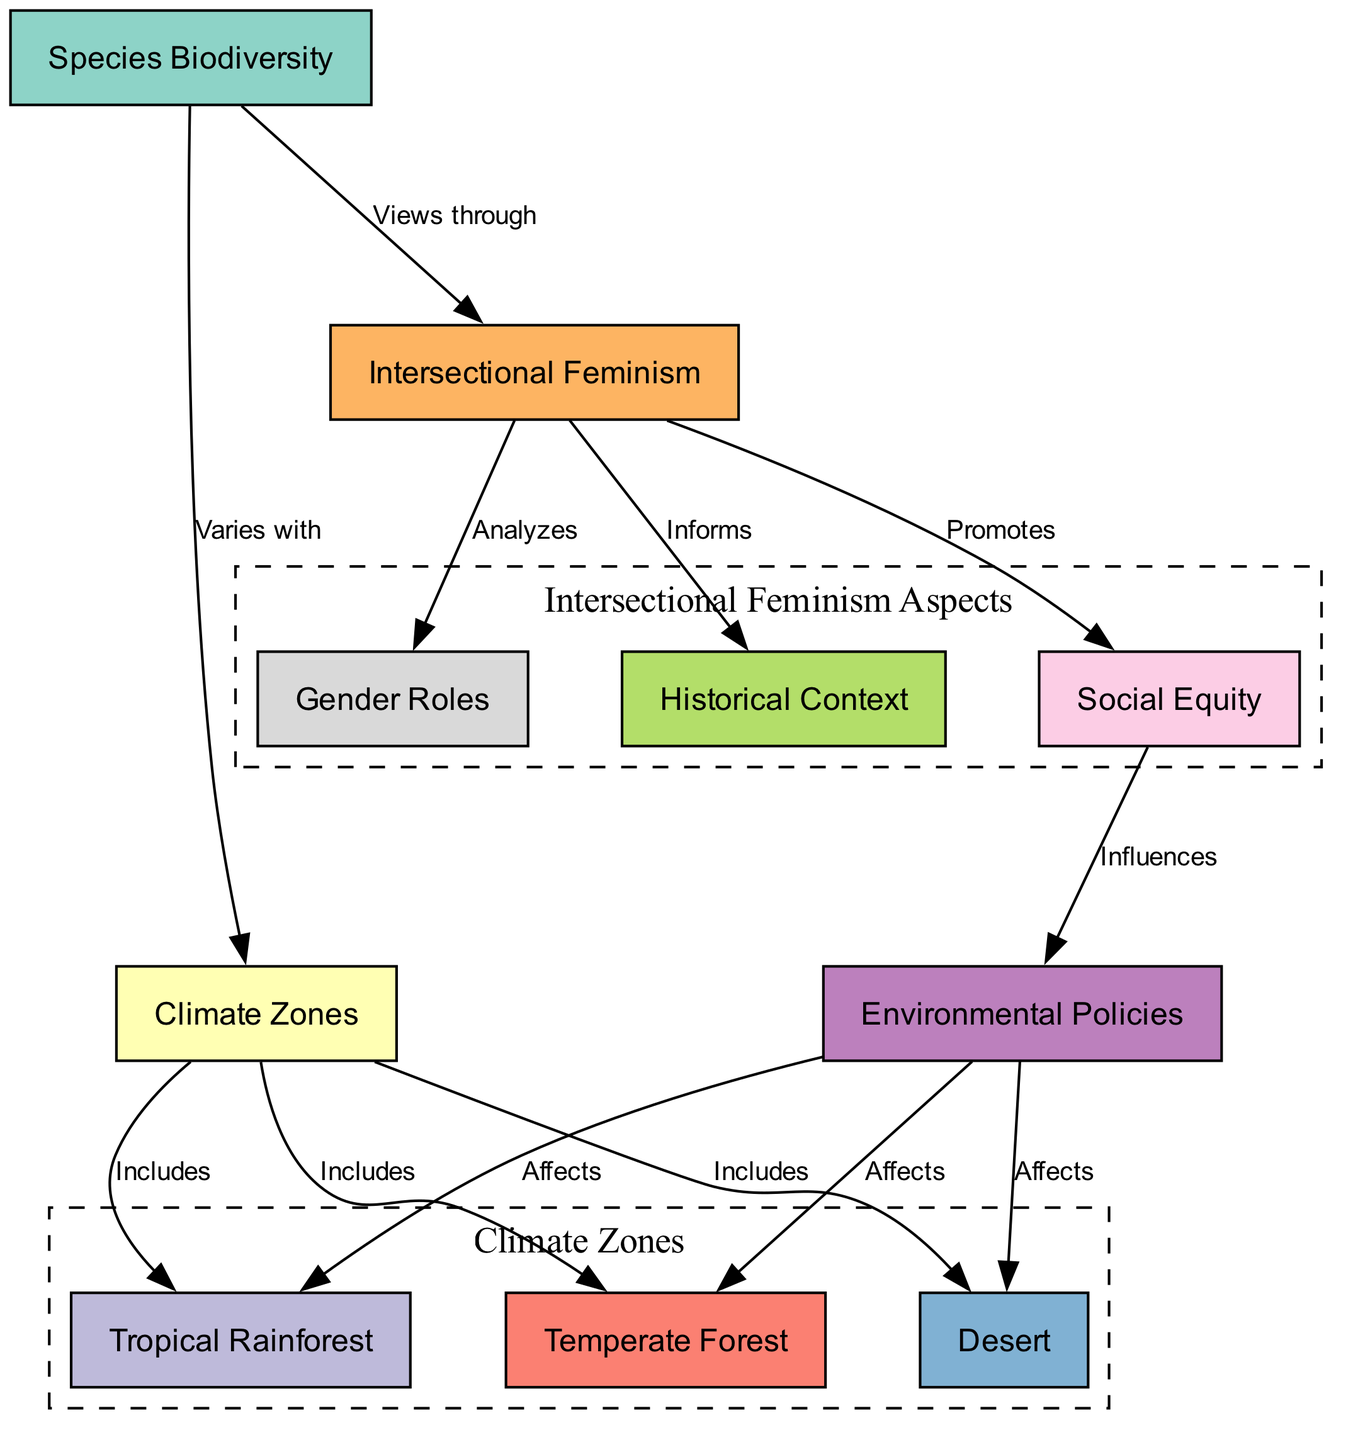What are the three climate zones included in the diagram? The diagram lists three specific climate zones that fall under the "Includes" relationship from the "Climate Zones" node: Tropical Rainforest, Temperate Forest, and Desert.
Answer: Tropical Rainforest, Temperate Forest, Desert How many nodes are present in the diagram? By counting all the distinct nodes listed in the diagram, including Species Biodiversity, Climate Zones, the three specific climate zones, Intersectional Feminism, and its related aspects, we find a total of ten nodes.
Answer: Ten What does intersectional feminism analyze according to the diagram? The diagram indicates that Intersectional Feminism analyzes gender roles. This is shown by the directed edge from the Intersectional Feminism node to the Gender Roles node, labeled "Analyzes."
Answer: Gender Roles Which node is influenced by social equity according to the diagram? The diagram shows that social equity influences environmental policies. There is a direct edge from the Social Equity node to the Environmental Policies node labeled "Influences."
Answer: Environmental Policies How many edges are connected to the climate zones node? To determine the number of edges connected to the Climate Zones node, we count the edges leading to each of the three climate zones as well as the edge leading to the Species Biodiversity node. This totals four edges.
Answer: Four What does species biodiversity view through? The diagram states that Species Biodiversity views through intersectional feminism, indicated by the edge connecting the Species Biodiversity node to the Intersectional Feminism node, labeled "Views through."
Answer: Intersectional Feminism Which climate zone is affected by environmental policies? The diagram clarifies that environmental policies affect all three climate zones: Tropical Rainforest, Temperate Forest, and Desert. However, the question seeks a specific answer, and the first listed one can be used here.
Answer: Tropical Rainforest What informs intersectional feminism in the diagram? The diagram establishes that the historical context informs intersectional feminism by showing a directed edge from the Historical Context node to the Intersectional Feminism node labeled "Informs."
Answer: Historical Context Which aspect of intersectional feminism promotes social equity? Within the diagram, it is shown that intersectional feminism promotes social equity. This is represented by a directed edge from the Intersectional Feminism node to the Social Equity node labeled "Promotes."
Answer: Social Equity 